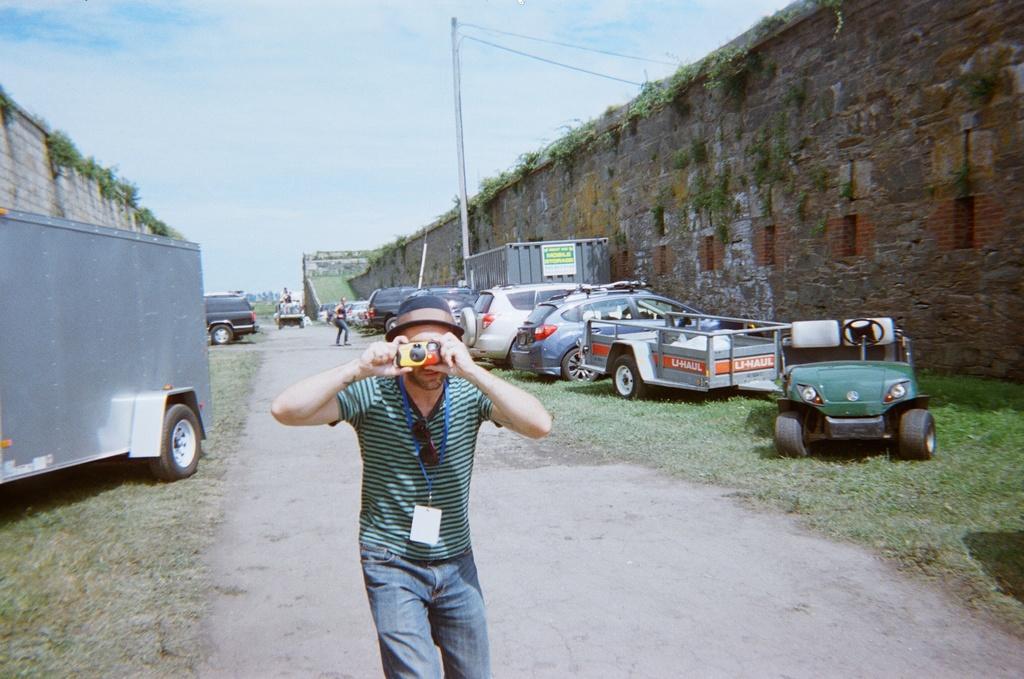Describe this image in one or two sentences. There is a person wearing tag and a cap is holding a camera. There is a road. On the sides of the road there are vehicles and grass. Also there are walls. On the walls there are plants. And there is a pole. In the background there is sky. 